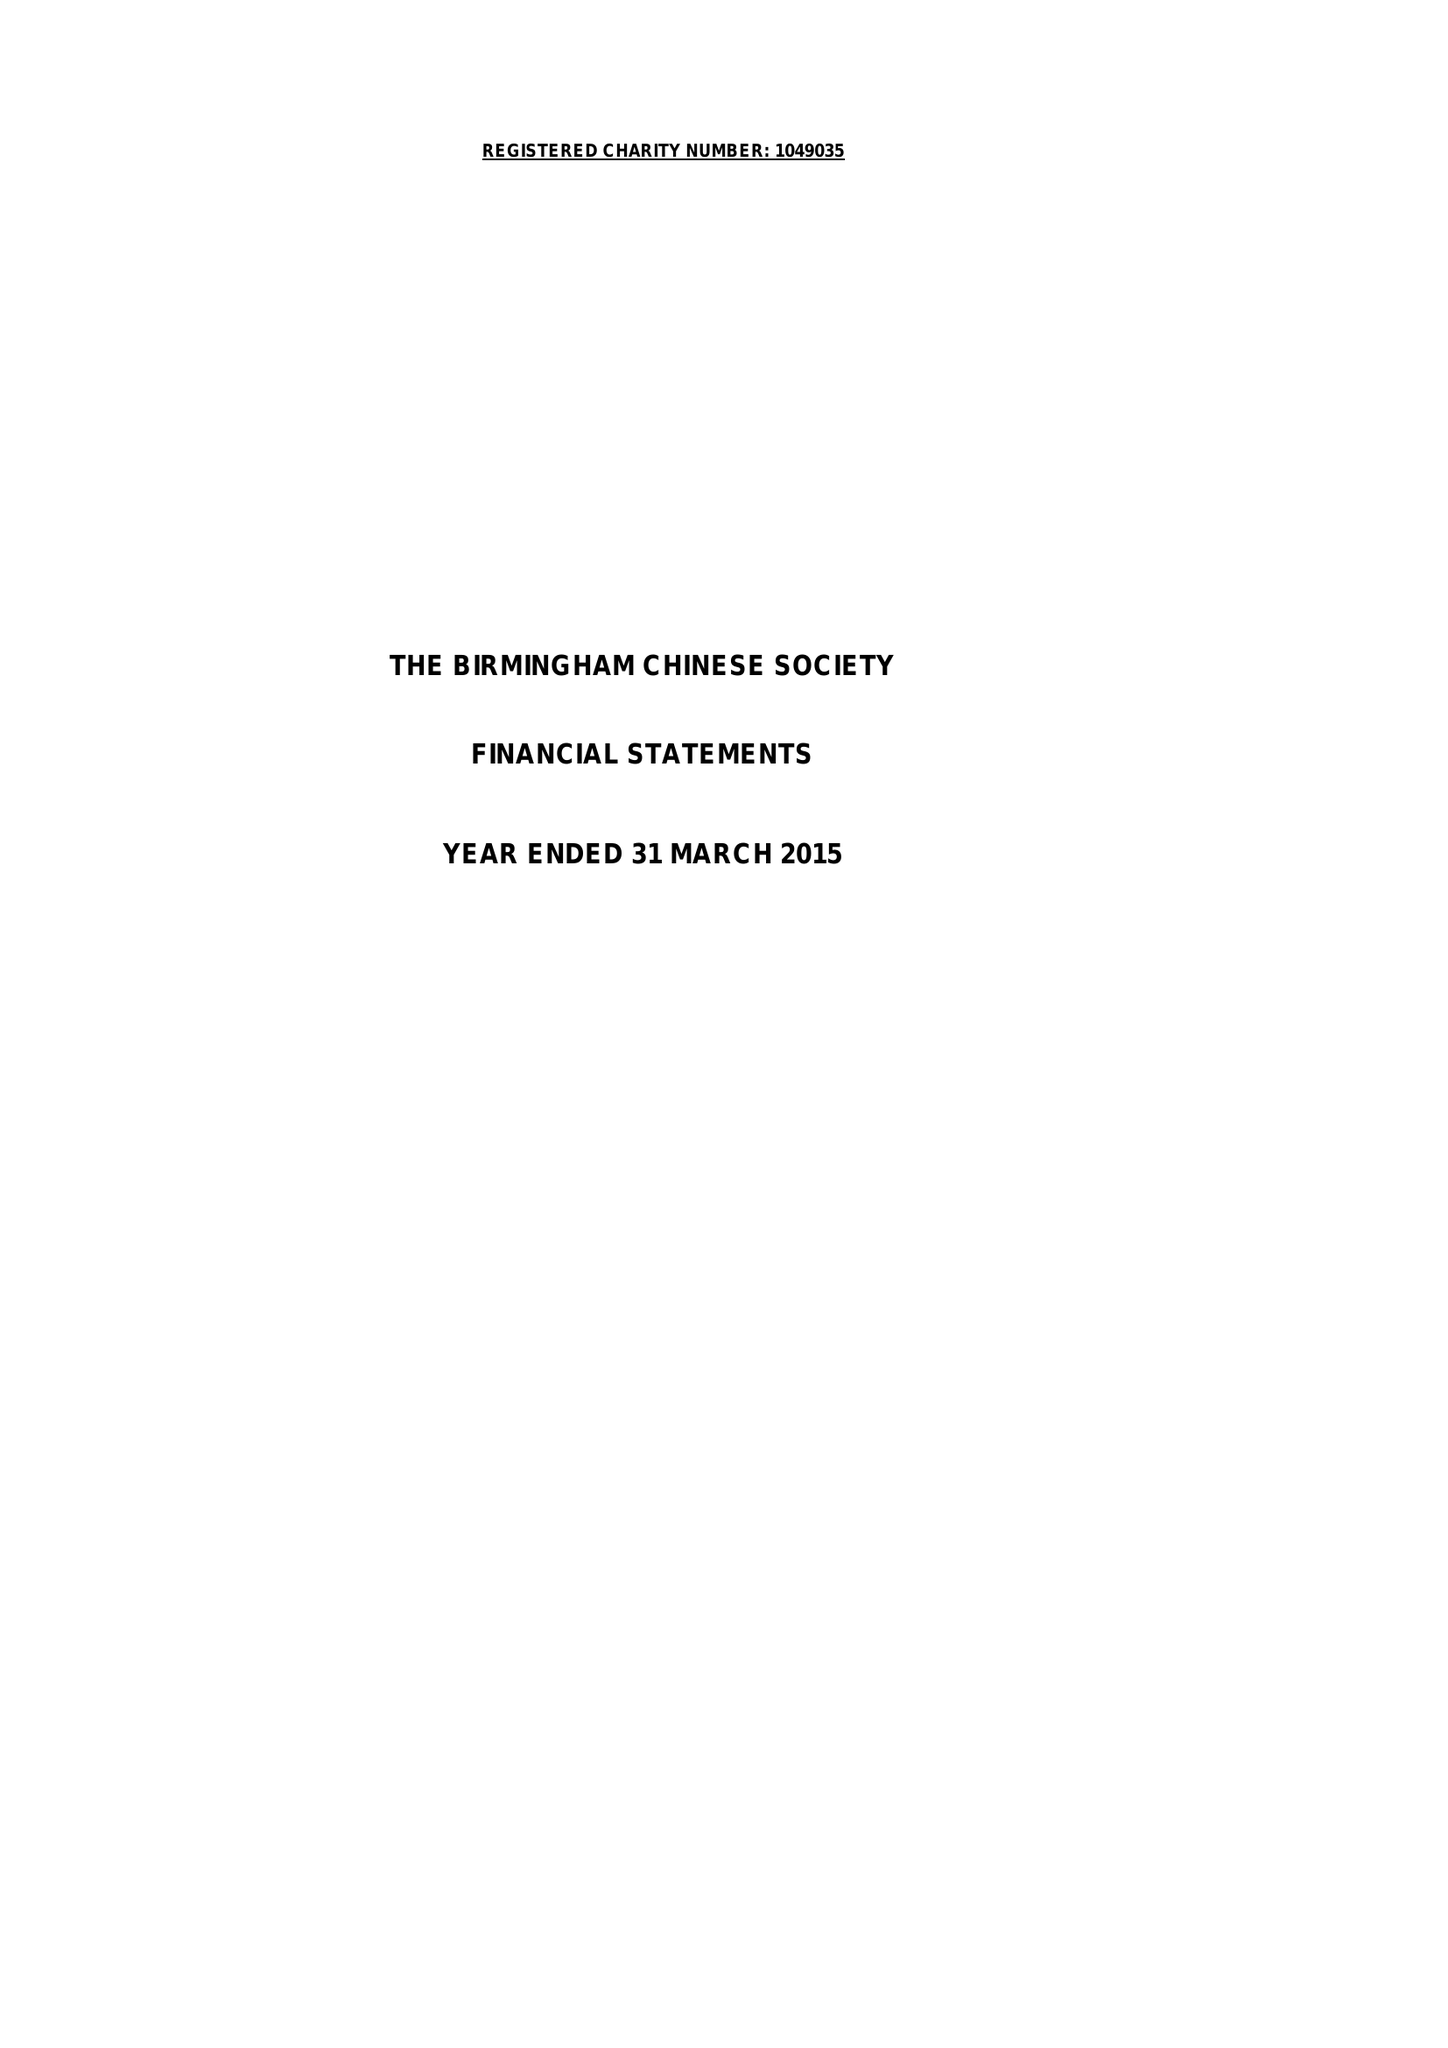What is the value for the address__street_line?
Answer the question using a single word or phrase. 11 ALLCOCK STREET 